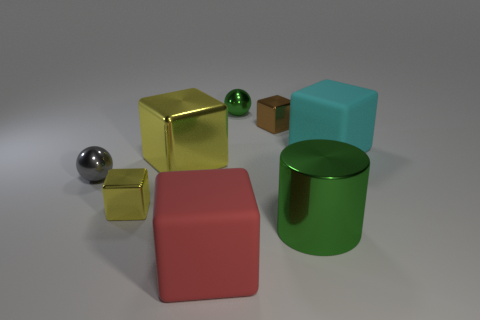How many other things are there of the same color as the metal cylinder?
Keep it short and to the point. 1. There is a cylinder; is it the same color as the tiny ball that is to the right of the big yellow block?
Provide a short and direct response. Yes. There is a big metal object behind the green cylinder; does it have the same color as the tiny metallic block that is in front of the cyan block?
Make the answer very short. Yes. How many large objects are either gray shiny spheres or red matte blocks?
Your response must be concise. 1. What number of tiny metal balls are there?
Give a very brief answer. 2. Is the number of cyan rubber things that are behind the large yellow metallic object the same as the number of brown metal things that are on the left side of the gray metallic object?
Provide a short and direct response. No. Are there any cubes behind the small gray metallic thing?
Your answer should be very brief. Yes. There is a rubber object that is on the right side of the large cylinder; what color is it?
Provide a succinct answer. Cyan. What is the material of the big cube right of the tiny thing behind the tiny brown shiny object?
Your response must be concise. Rubber. Are there fewer big green cylinders in front of the cylinder than big green cylinders on the left side of the red thing?
Your answer should be very brief. No. 